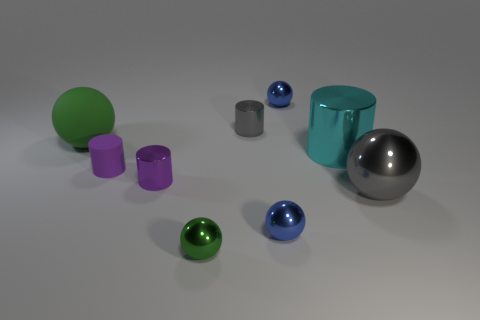Subtract 2 cylinders. How many cylinders are left? 2 Subtract all gray spheres. How many spheres are left? 4 Subtract all green matte balls. How many balls are left? 4 Subtract all brown cylinders. Subtract all blue blocks. How many cylinders are left? 4 Subtract all cylinders. How many objects are left? 5 Subtract all large cyan shiny balls. Subtract all matte cylinders. How many objects are left? 8 Add 1 metal spheres. How many metal spheres are left? 5 Add 1 large matte balls. How many large matte balls exist? 2 Subtract 1 gray balls. How many objects are left? 8 